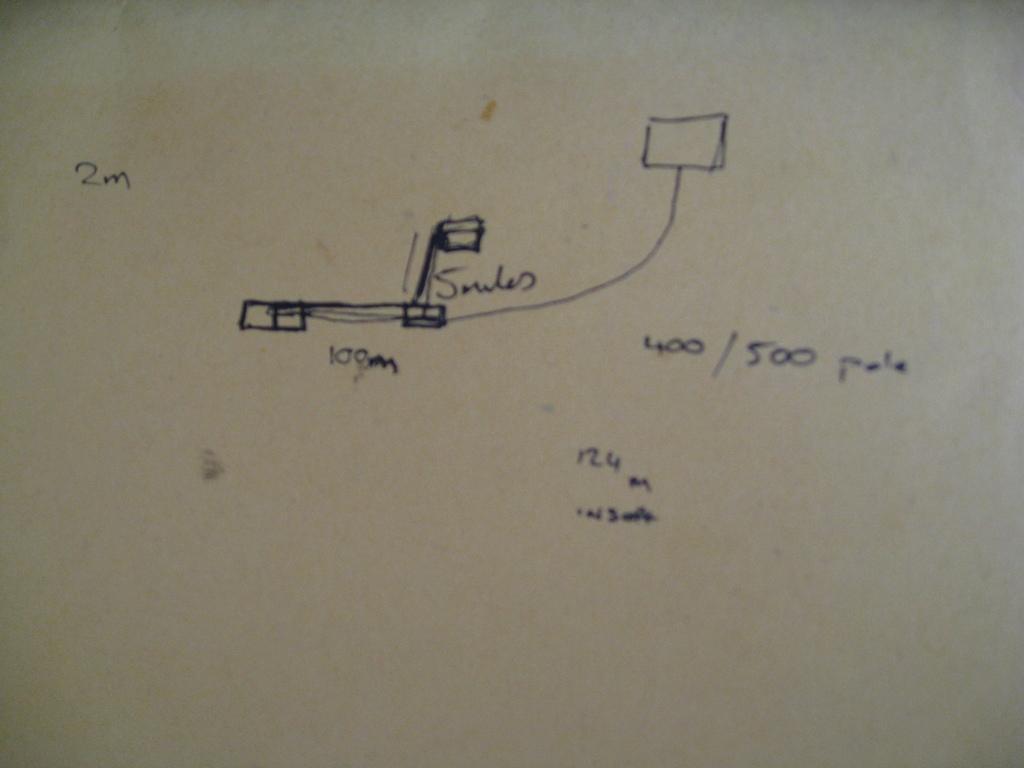Provide a one-sentence caption for the provided image. A drawing of measurements of an item including 100m, 2m, and a 400/500 pole. 